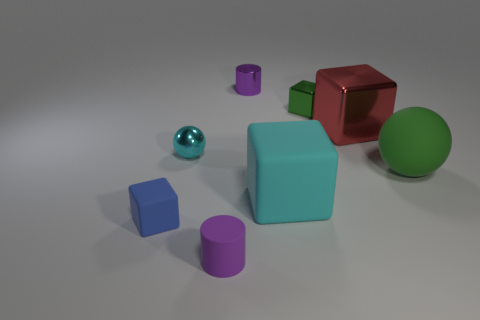How many things are either small cubes that are in front of the large matte sphere or objects in front of the large red shiny thing?
Give a very brief answer. 5. Is the size of the shiny sphere the same as the green ball?
Keep it short and to the point. No. There is a rubber object that is on the right side of the big cyan cube; is it the same shape as the tiny purple object that is in front of the large red thing?
Provide a short and direct response. No. The cyan ball has what size?
Offer a very short reply. Small. There is a small cube that is behind the tiny cube that is in front of the small cyan ball that is to the left of the cyan rubber block; what is its material?
Your response must be concise. Metal. What number of other things are there of the same color as the large metal object?
Your answer should be very brief. 0. How many blue things are small metal blocks or tiny cylinders?
Your answer should be compact. 0. What is the purple object in front of the blue cube made of?
Your answer should be very brief. Rubber. Is the material of the green object to the left of the red metal thing the same as the cyan block?
Ensure brevity in your answer.  No. What is the shape of the big green object?
Your answer should be compact. Sphere. 